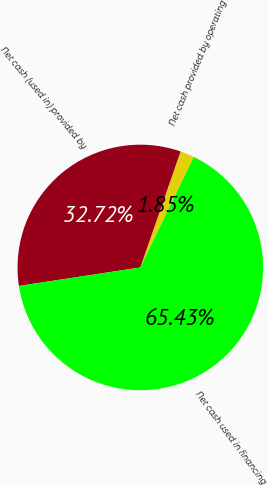<chart> <loc_0><loc_0><loc_500><loc_500><pie_chart><fcel>Net cash provided by operating<fcel>Net cash (used in) provided by<fcel>Net cash used in financing<nl><fcel>1.85%<fcel>32.72%<fcel>65.43%<nl></chart> 